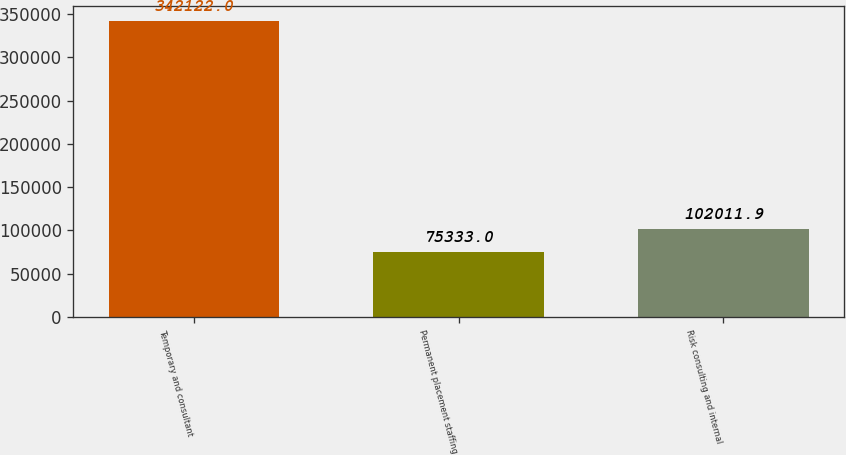Convert chart. <chart><loc_0><loc_0><loc_500><loc_500><bar_chart><fcel>Temporary and consultant<fcel>Permanent placement staffing<fcel>Risk consulting and internal<nl><fcel>342122<fcel>75333<fcel>102012<nl></chart> 